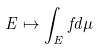Convert formula to latex. <formula><loc_0><loc_0><loc_500><loc_500>E \mapsto \int _ { E } f d \mu</formula> 